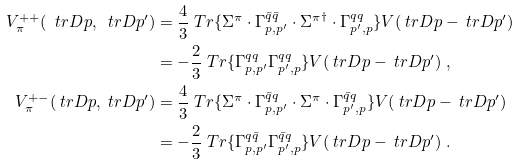<formula> <loc_0><loc_0><loc_500><loc_500>V _ { \pi } ^ { + + } ( \ t r D { p } , \ t r D { p } ^ { \prime } ) & = \frac { 4 } { 3 } \ T r \{ \Sigma ^ { \pi } \cdot \Gamma ^ { \bar { q } \bar { q } } _ { p , p ^ { \prime } } \cdot { \Sigma ^ { \pi } } ^ { \dag } \cdot \Gamma ^ { q q } _ { p ^ { \prime } , p } \} V ( \ t r D { p } - \ t r D { p } ^ { \prime } ) \\ & = - \frac { 2 } { 3 } \ T r \{ \Gamma ^ { q q } _ { p , p ^ { \prime } } \Gamma ^ { q q } _ { p ^ { \prime } , p } \} V ( \ t r D { p } - \ t r D { p } ^ { \prime } ) \ , \\ V _ { \pi } ^ { + - } ( \ t r D { p } , \ t r D { p } ^ { \prime } ) & = \frac { 4 } { 3 } \ T r \{ \Sigma ^ { \pi } \cdot \Gamma ^ { \bar { q } q } _ { p , p ^ { \prime } } \cdot \Sigma ^ { \pi } \cdot \Gamma ^ { \bar { q } q } _ { p ^ { \prime } , p } \} V ( \ t r D { p } - \ t r D { p } ^ { \prime } ) \\ & = - \frac { 2 } { 3 } \ T r \{ \Gamma ^ { q \bar { q } } _ { p , p ^ { \prime } } \Gamma ^ { \bar { q } q } _ { p ^ { \prime } , p } \} V ( \ t r D { p } - \ t r D { p } ^ { \prime } ) \ .</formula> 